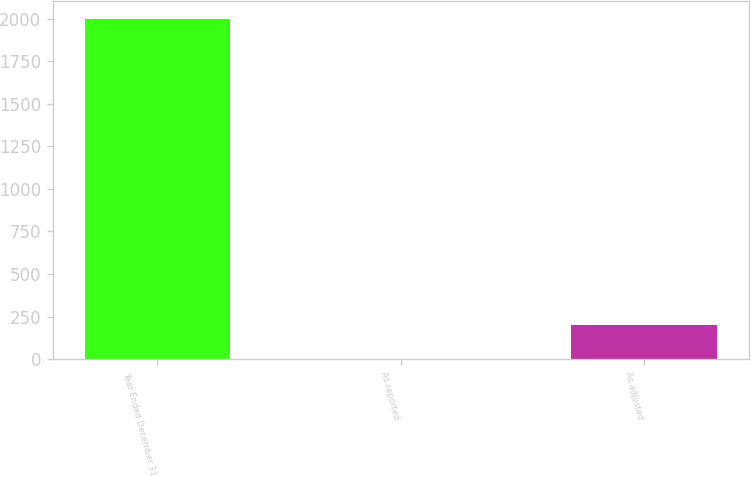Convert chart. <chart><loc_0><loc_0><loc_500><loc_500><bar_chart><fcel>Year Ended December 31<fcel>As reported<fcel>As adjusted<nl><fcel>2001<fcel>0.94<fcel>200.95<nl></chart> 